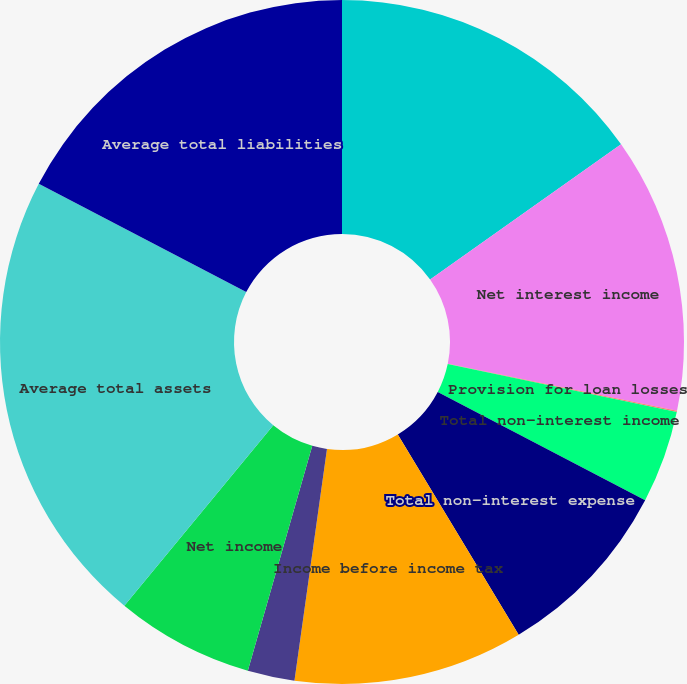Convert chart to OTSL. <chart><loc_0><loc_0><loc_500><loc_500><pie_chart><fcel>Years ended December 31 (in<fcel>Net interest income<fcel>Provision for loan losses<fcel>Total non-interest income<fcel>Total non-interest expense<fcel>Income before income tax<fcel>Income tax expense<fcel>Net income<fcel>Average total assets<fcel>Average total liabilities<nl><fcel>15.19%<fcel>13.03%<fcel>0.06%<fcel>4.38%<fcel>8.7%<fcel>10.86%<fcel>2.22%<fcel>6.54%<fcel>21.67%<fcel>17.35%<nl></chart> 